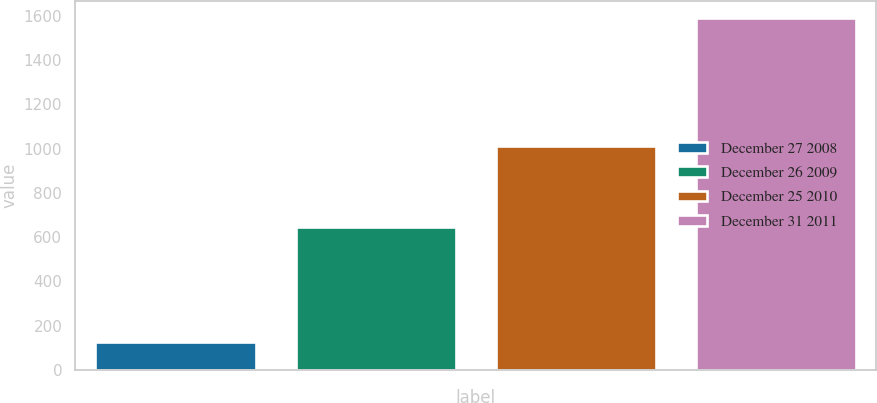<chart> <loc_0><loc_0><loc_500><loc_500><bar_chart><fcel>December 27 2008<fcel>December 26 2009<fcel>December 25 2010<fcel>December 31 2011<nl><fcel>127<fcel>648<fcel>1013<fcel>1590<nl></chart> 